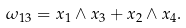<formula> <loc_0><loc_0><loc_500><loc_500>\omega _ { 1 3 } = x _ { 1 } \wedge x _ { 3 } + x _ { 2 } \wedge x _ { 4 } .</formula> 